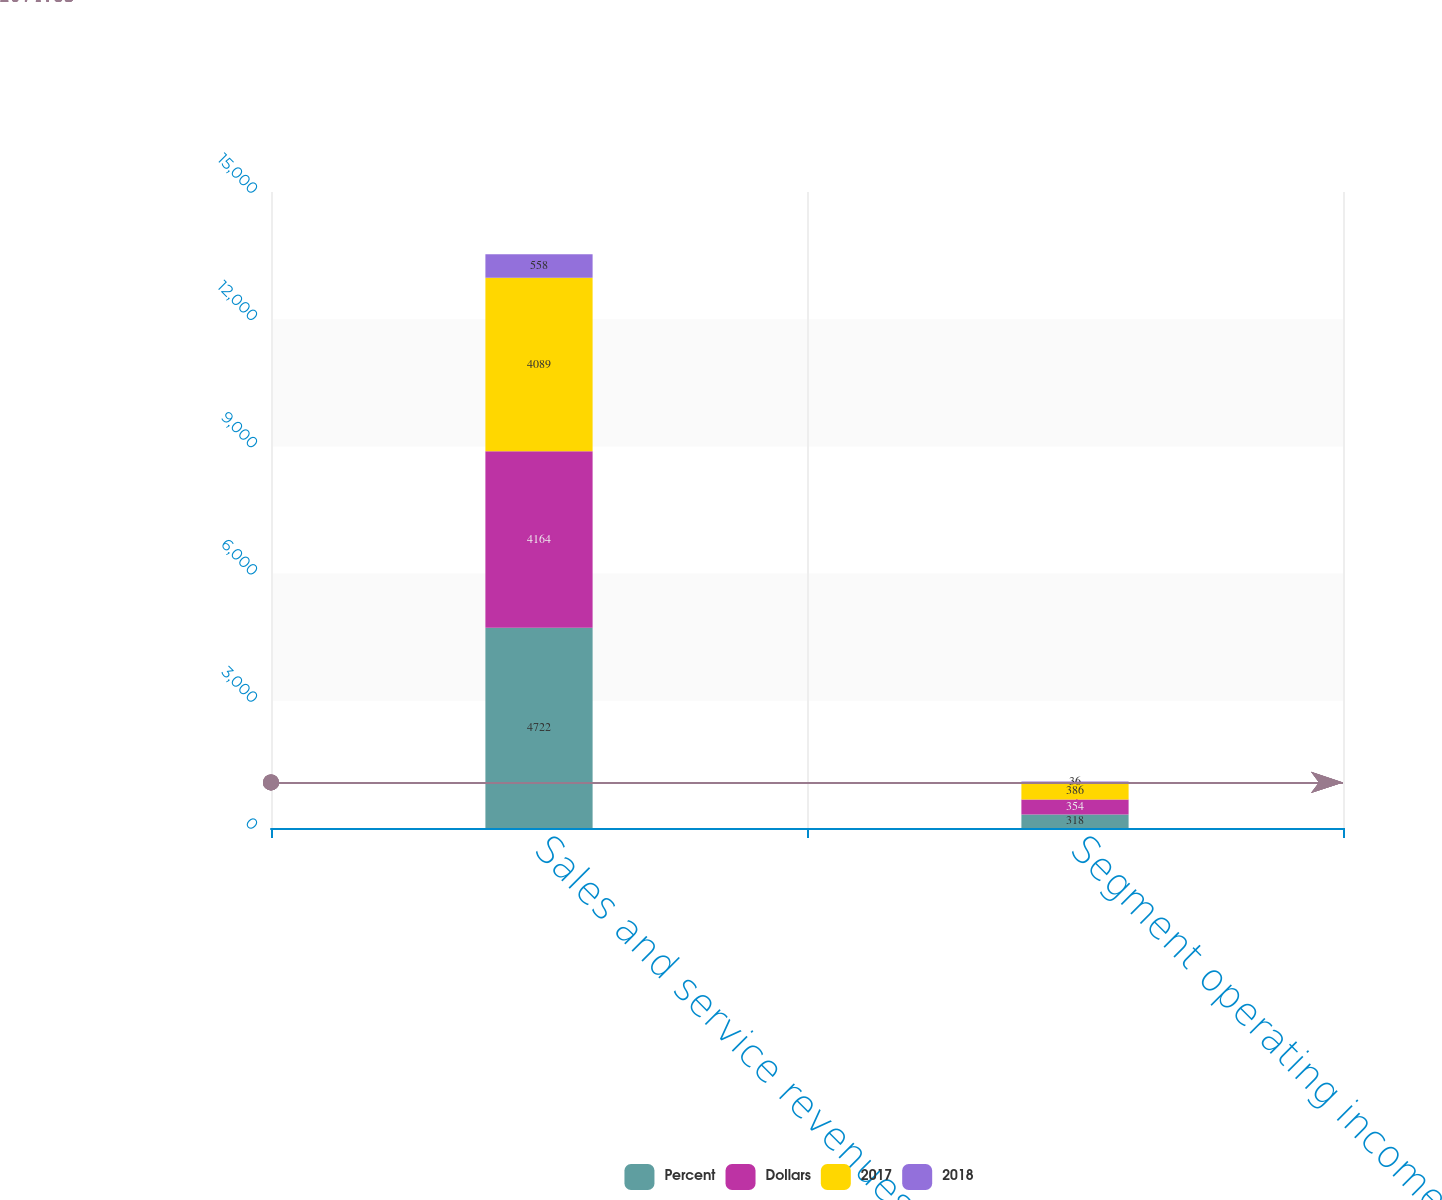Convert chart to OTSL. <chart><loc_0><loc_0><loc_500><loc_500><stacked_bar_chart><ecel><fcel>Sales and service revenues<fcel>Segment operating income<nl><fcel>Percent<fcel>4722<fcel>318<nl><fcel>Dollars<fcel>4164<fcel>354<nl><fcel>2017<fcel>4089<fcel>386<nl><fcel>2018<fcel>558<fcel>36<nl></chart> 